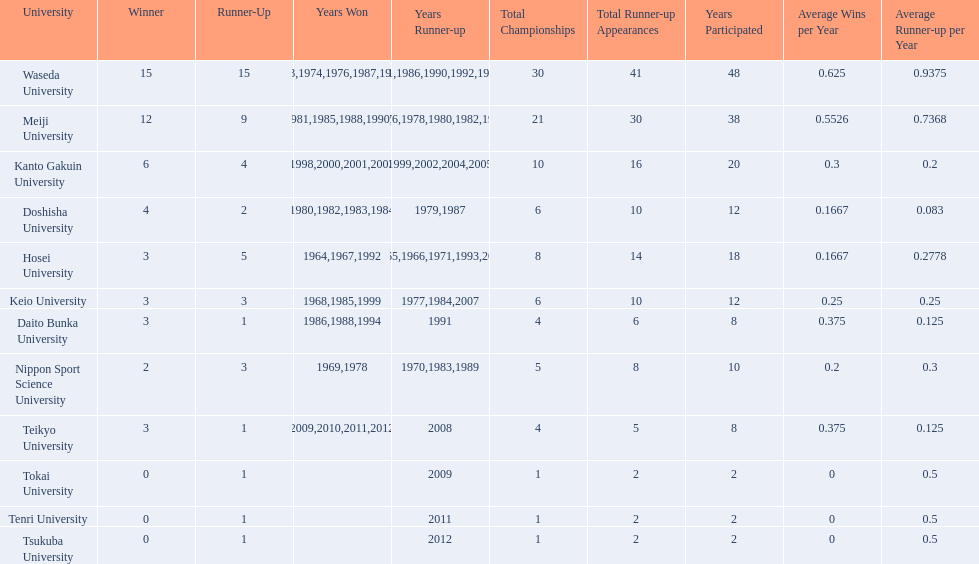What university were there in the all-japan university rugby championship? Waseda University, Meiji University, Kanto Gakuin University, Doshisha University, Hosei University, Keio University, Daito Bunka University, Nippon Sport Science University, Teikyo University, Tokai University, Tenri University, Tsukuba University. Of these who had more than 12 wins? Waseda University. Could you help me parse every detail presented in this table? {'header': ['University', 'Winner', 'Runner-Up', 'Years Won', 'Years Runner-up', 'Total Championships', 'Total Runner-up Appearances', 'Years Participated', 'Average Wins per Year', 'Average Runner-up per Year'], 'rows': [['Waseda University', '15', '15', '1965,1966,1968,1970,1971,1973,1974,1976,1987,1989,\\n2002,2004,2005,2007,2008', '1964,1967,1969,1972,1975,1981,1986,1990,1992,1995,\\n1996,2001,2003,2006,2010', '30', '41', '48', '0.625', '0.9375'], ['Meiji University', '12', '9', '1972,1975,1977,1979,1981,1985,1988,1990,1991,1993,\\n1995,1996', '1973,1974,1976,1978,1980,1982,1994,1997,1998', '21', '30', '38', '0.5526', '0.7368'], ['Kanto Gakuin University', '6', '4', '1997,1998,2000,2001,2003,2006', '1999,2002,2004,2005', '10', '16', '20', '0.3', '0.2'], ['Doshisha University', '4', '2', '1980,1982,1983,1984', '1979,1987', '6', '10', '12', '0.1667', '0.083'], ['Hosei University', '3', '5', '1964,1967,1992', '1965,1966,1971,1993,2000', '8', '14', '18', '0.1667', '0.2778'], ['Keio University', '3', '3', '1968,1985,1999', '1977,1984,2007', '6', '10', '12', '0.25', '0.25'], ['Daito Bunka University', '3', '1', '1986,1988,1994', '1991', '4', '6', '8', '0.375', '0.125'], ['Nippon Sport Science University', '2', '3', '1969,1978', '1970,1983,1989', '5', '8', '10', '0.2', '0.3'], ['Teikyo University', '3', '1', '2009,2010,2011,2012', '2008', '4', '5', '8', '0.375', '0.125'], ['Tokai University', '0', '1', '', '2009', '1', '2', '2', '0', '0.5'], ['Tenri University', '0', '1', '', '2011', '1', '2', '2', '0', '0.5'], ['Tsukuba University', '0', '1', '', '2012', '1', '2', '2', '0', '0.5']]} 